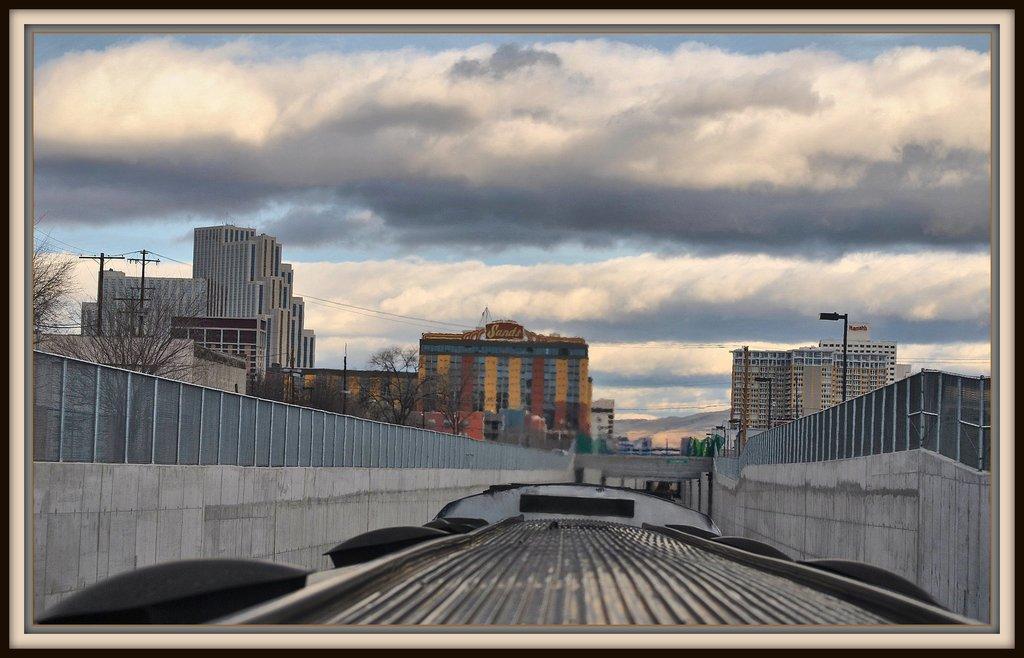Can you describe this image briefly? This image has borders. In the center of the image we can see a top view of a vehicle. There are fencing's to both sides of the image. In the background of the image there are buildings, poles, sky and clouds. There are trees. 